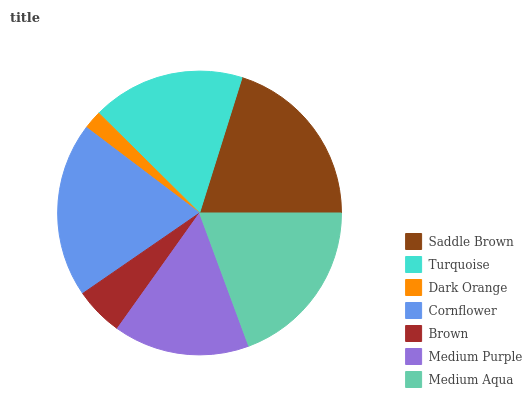Is Dark Orange the minimum?
Answer yes or no. Yes. Is Saddle Brown the maximum?
Answer yes or no. Yes. Is Turquoise the minimum?
Answer yes or no. No. Is Turquoise the maximum?
Answer yes or no. No. Is Saddle Brown greater than Turquoise?
Answer yes or no. Yes. Is Turquoise less than Saddle Brown?
Answer yes or no. Yes. Is Turquoise greater than Saddle Brown?
Answer yes or no. No. Is Saddle Brown less than Turquoise?
Answer yes or no. No. Is Turquoise the high median?
Answer yes or no. Yes. Is Turquoise the low median?
Answer yes or no. Yes. Is Cornflower the high median?
Answer yes or no. No. Is Dark Orange the low median?
Answer yes or no. No. 